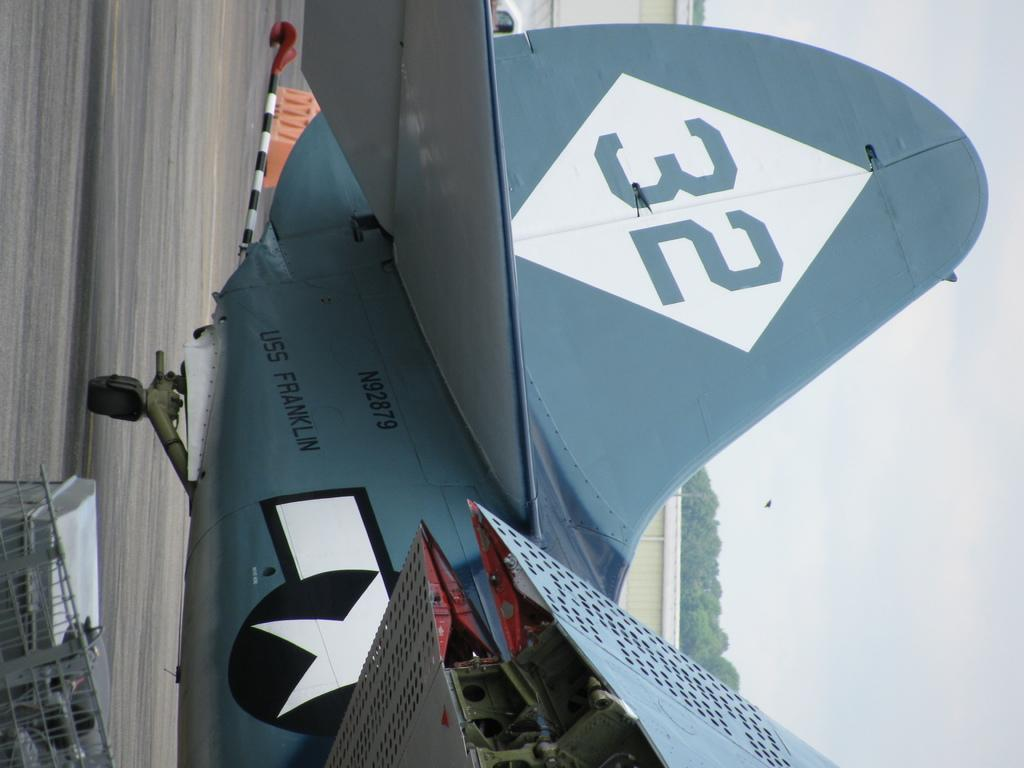<image>
Relay a brief, clear account of the picture shown. a plane that has the number 32 on the back 